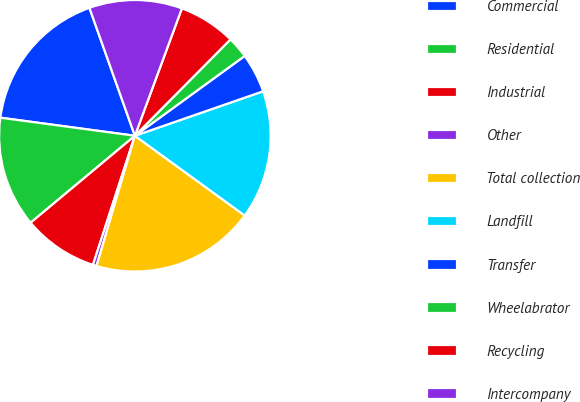Convert chart to OTSL. <chart><loc_0><loc_0><loc_500><loc_500><pie_chart><fcel>Commercial<fcel>Residential<fcel>Industrial<fcel>Other<fcel>Total collection<fcel>Landfill<fcel>Transfer<fcel>Wheelabrator<fcel>Recycling<fcel>Intercompany<nl><fcel>17.44%<fcel>13.19%<fcel>8.94%<fcel>0.44%<fcel>19.56%<fcel>15.31%<fcel>4.69%<fcel>2.56%<fcel>6.81%<fcel>11.06%<nl></chart> 